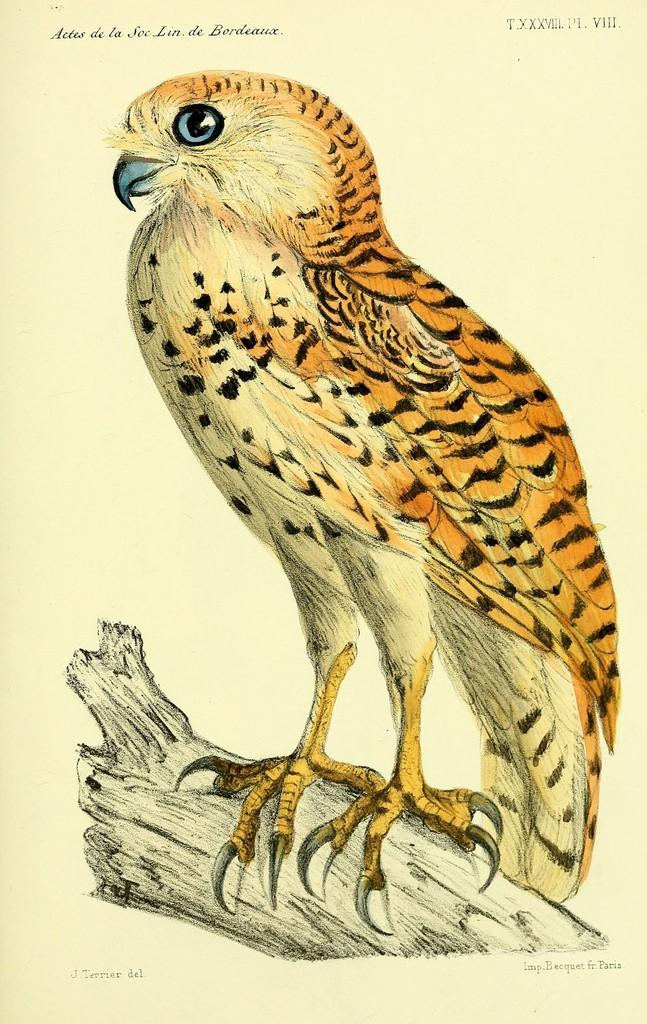What is depicted in the painting in the image? The painting contains a bird. How is the bird positioned in the painting? The bird is on a stick and facing towards the left side. What can be seen at the top of the image? There is text visible at the top of the image. What type of attraction can be seen in the background of the image? There is no attraction visible in the image; it only contains a painting of a bird on a stick. How many fans are present in the image? There are no fans visible in the image. 